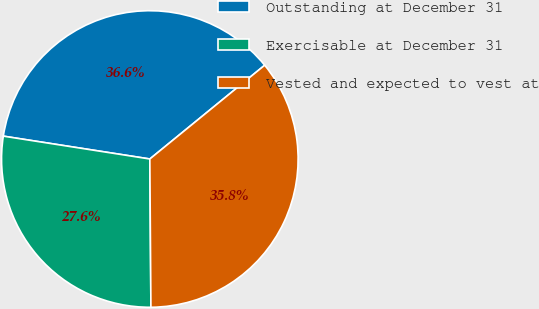<chart> <loc_0><loc_0><loc_500><loc_500><pie_chart><fcel>Outstanding at December 31<fcel>Exercisable at December 31<fcel>Vested and expected to vest at<nl><fcel>36.64%<fcel>27.58%<fcel>35.78%<nl></chart> 